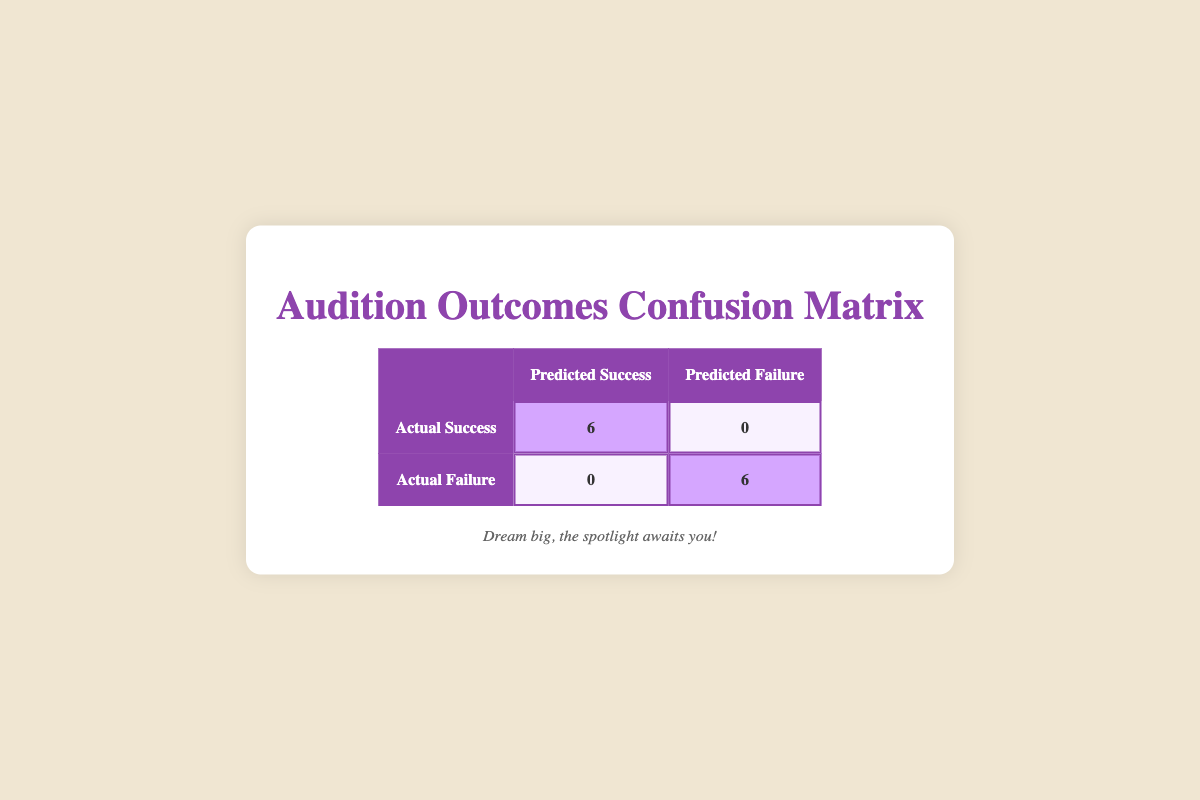What is the total number of audition outcomes categorized as success? The table indicates that there are 6 outcomes categorized as success, which can be seen in the "Actual Success" row corresponding to "Predicted Success."
Answer: 6 What is the total number of audition outcomes categorized as failure? The table indicates that there are 6 outcomes categorized as failure, reflected in the "Actual Failure" row under "Predicted Failure."
Answer: 6 Did any actor who actually succeeded get predicted to fail? According to the table, under the "Actual Success" row, there are 0 counts for "Predicted Failure," which means no actor who actually succeeded was predicted to fail.
Answer: No Was there anyone predicted to succeed that actually failed? The table shows that under the "Actual Failure" row, the count for "Predicted Success" is 0. This means that there were no actors predicted to succeed who actually failed.
Answer: No What is the accuracy of the prediction model based on the outcomes given? To calculate accuracy, we consider the total number of correct predictions (success and failure). The table shows 6 correct successes and 6 correct failures, giving us a total of 12. Since there are no wrong predictions, the accuracy is (6 + 6) / 12 = 1 or 100%.
Answer: 100% How many actors are actually successful versus those who are predicted to be successful? The "Actual Success" count is 6, and the "Predicted Success" count is also 6, illustrating that every actor predicted to succeed ended up being successful.
Answer: Equal (6 each) What is the difference in the number of actual failure outcomes versus predicted failure outcomes? The "Actual Failure" count is 6 while the "Predicted Failure" count is also 6. Therefore, the difference is 6 - 6 = 0; there are no discrepancies.
Answer: 0 What is the total number of audition outcomes represented in the table? The sum of both success (6) and failure (6) gives us a total of 12 audition outcomes present in the table.
Answer: 12 